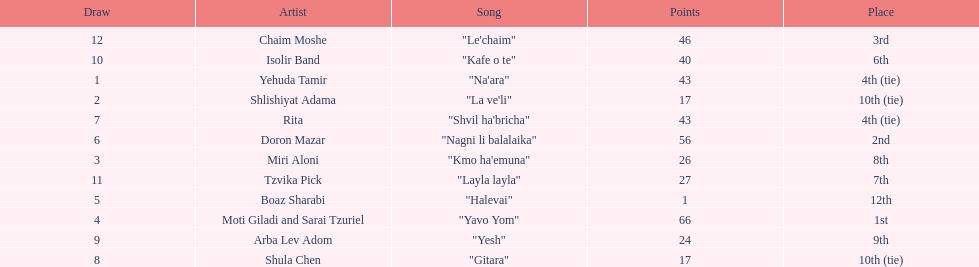Did the song "gitara" or "yesh" earn more points? "Yesh". 